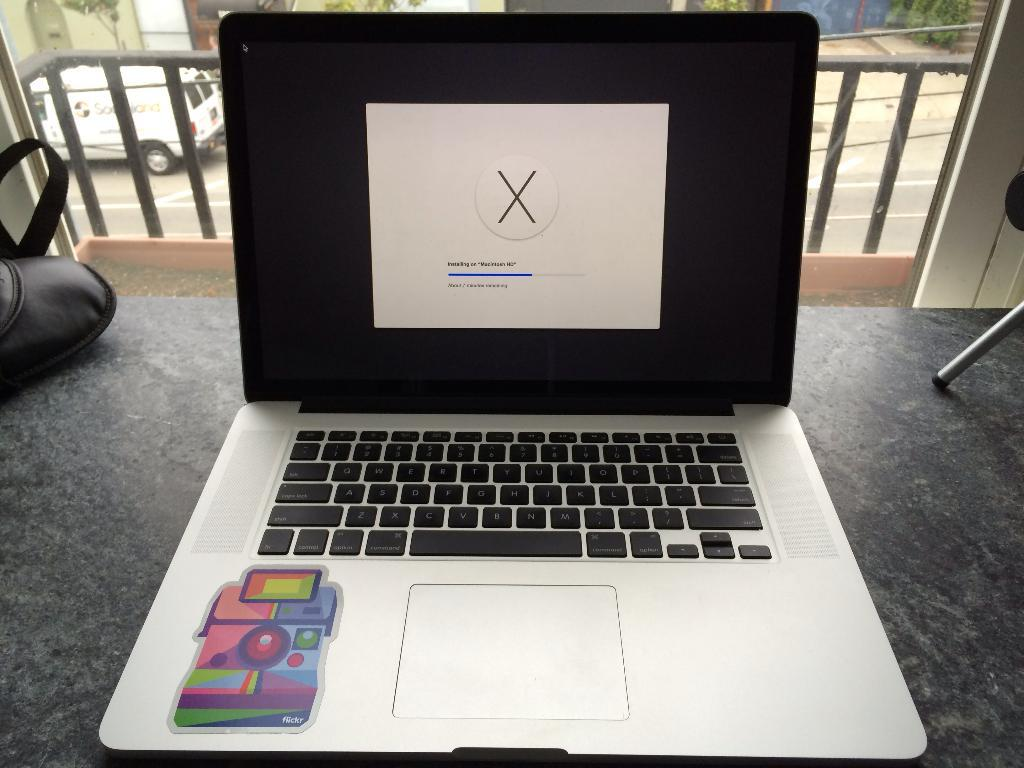What electronic device is on the floor in the image? There is a laptop on the floor. What can be seen in the background of the image? There is a fence and a vehicle in the background. What type of pan is hanging from the fence in the image? There is no pan present in the image; the background only features a fence and a vehicle. 